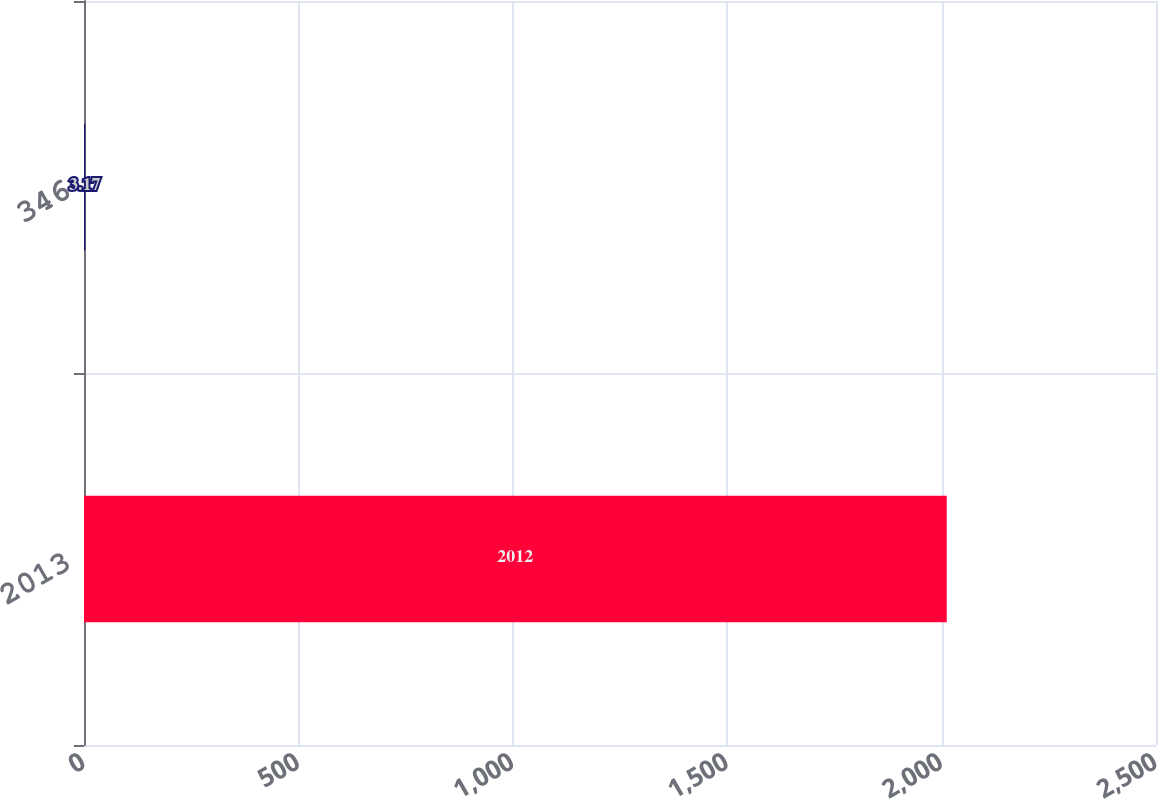Convert chart to OTSL. <chart><loc_0><loc_0><loc_500><loc_500><bar_chart><fcel>2013<fcel>346<nl><fcel>2012<fcel>3.17<nl></chart> 